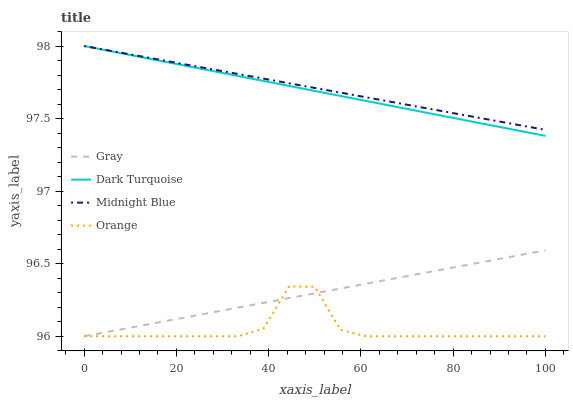Does Orange have the minimum area under the curve?
Answer yes or no. Yes. Does Midnight Blue have the maximum area under the curve?
Answer yes or no. Yes. Does Gray have the minimum area under the curve?
Answer yes or no. No. Does Gray have the maximum area under the curve?
Answer yes or no. No. Is Dark Turquoise the smoothest?
Answer yes or no. Yes. Is Orange the roughest?
Answer yes or no. Yes. Is Gray the smoothest?
Answer yes or no. No. Is Gray the roughest?
Answer yes or no. No. Does Midnight Blue have the lowest value?
Answer yes or no. No. Does Gray have the highest value?
Answer yes or no. No. Is Orange less than Dark Turquoise?
Answer yes or no. Yes. Is Dark Turquoise greater than Gray?
Answer yes or no. Yes. Does Orange intersect Dark Turquoise?
Answer yes or no. No. 